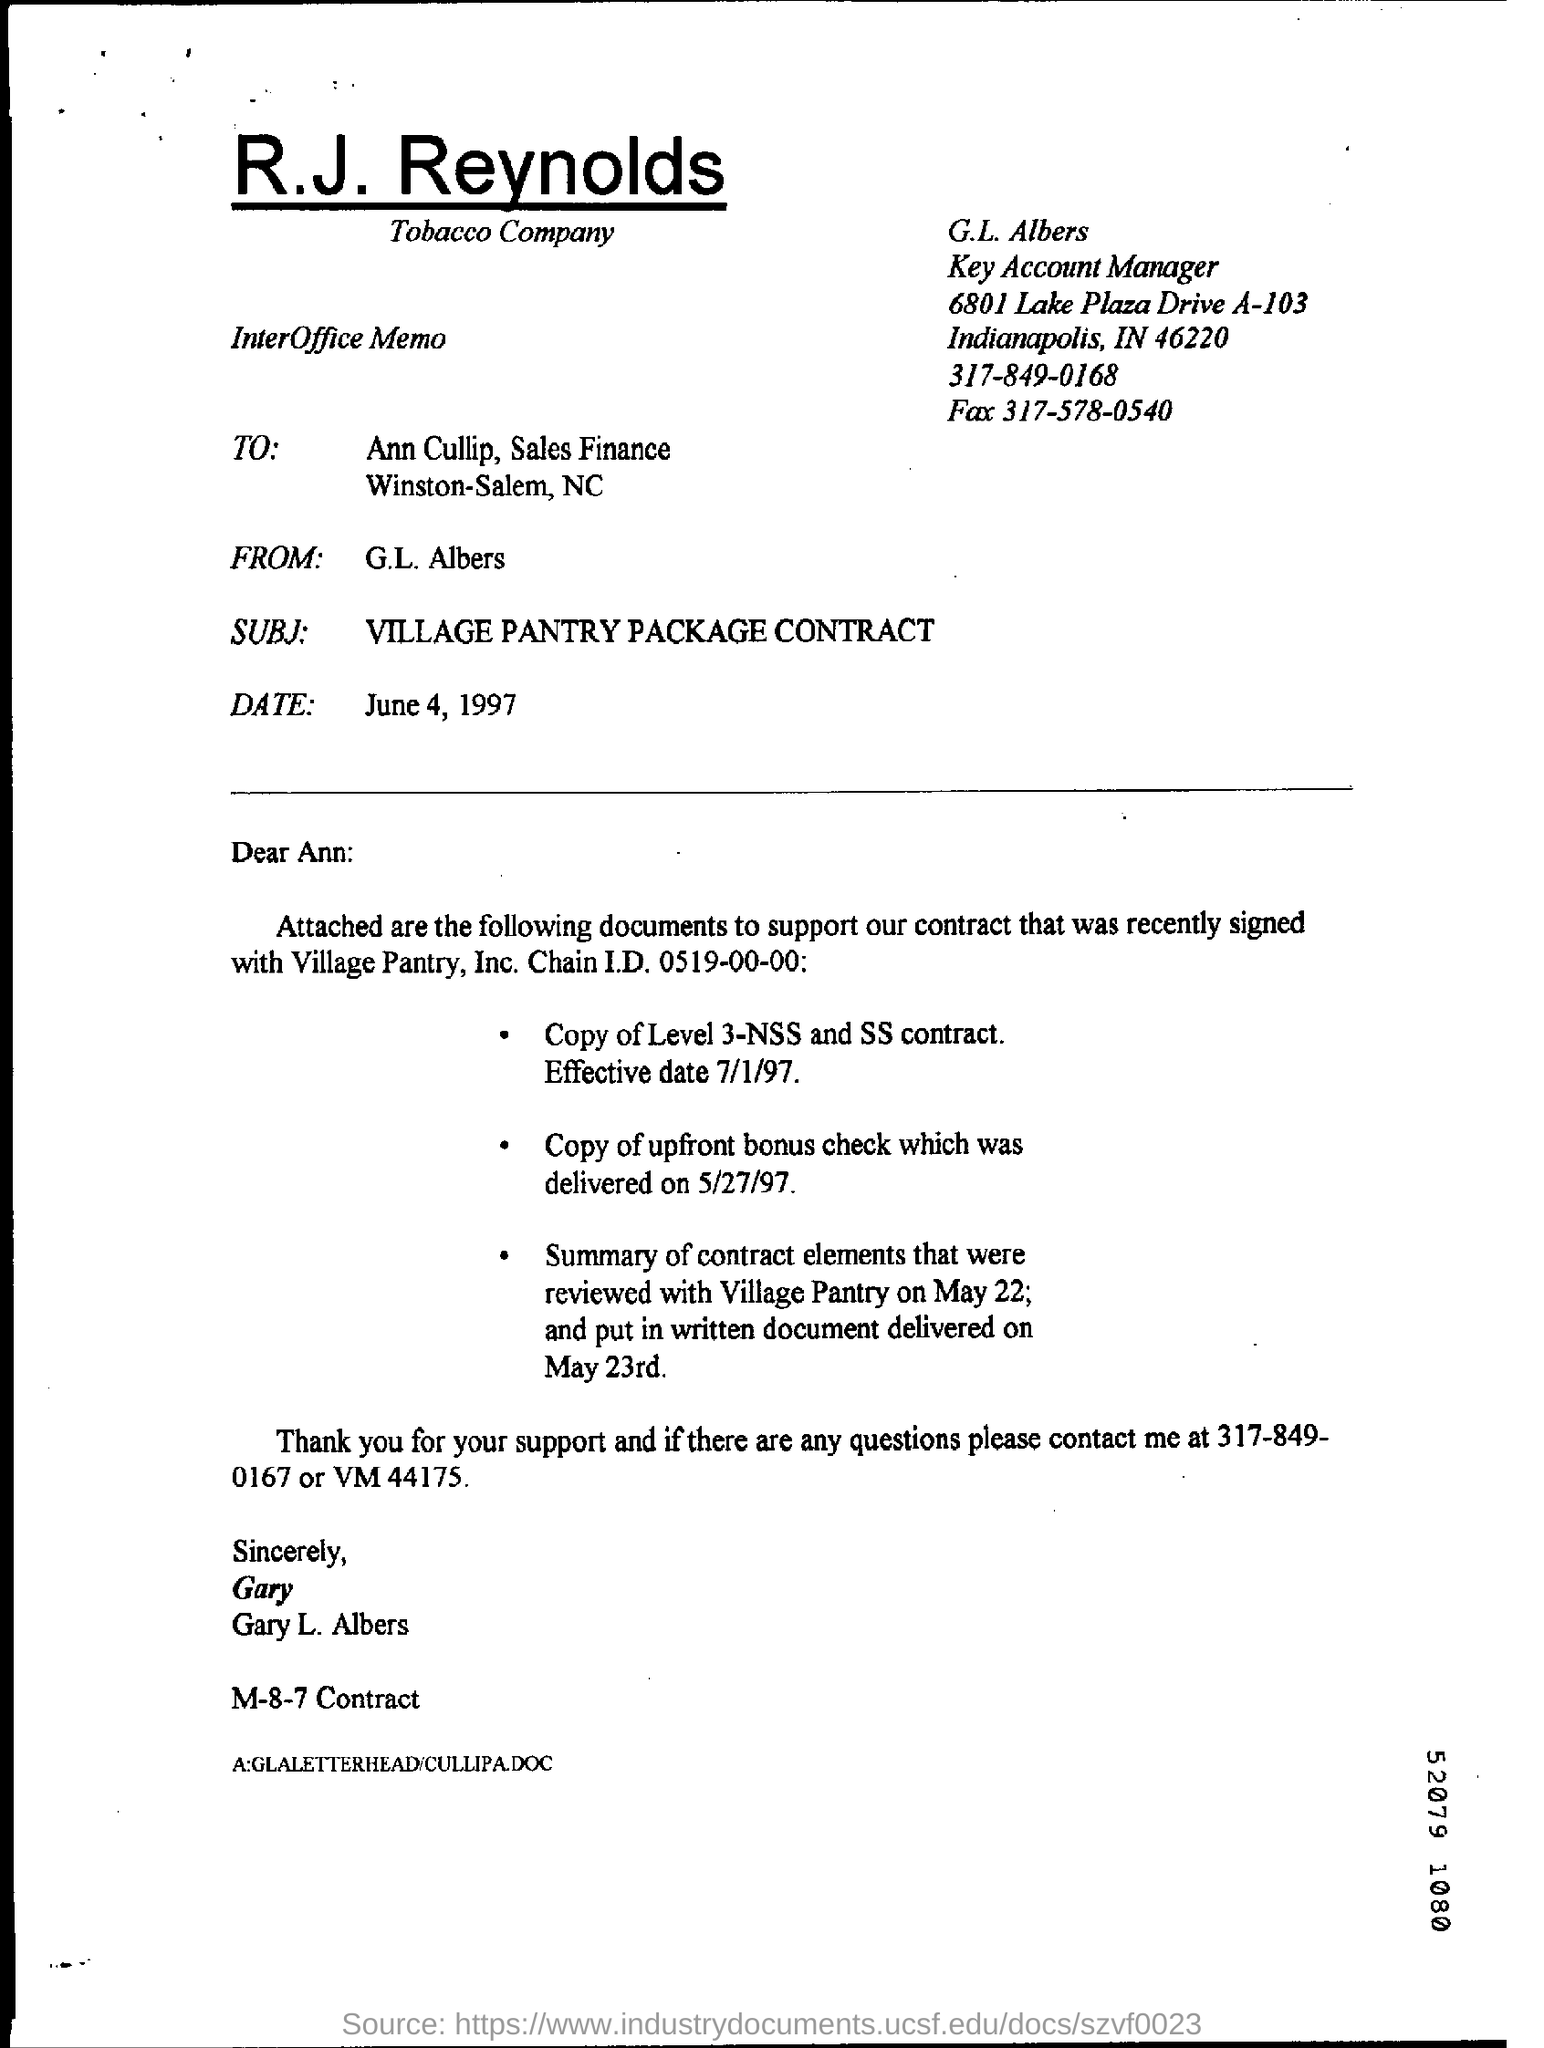When is the interoffice memo dated ?
Your answer should be compact. June 4, 1997. What is the street address of g.l albers ?
Provide a succinct answer. 6801 Lake Plaza Drive A-103. What is the position of g.l. albers?
Your answer should be very brief. Key account manager. 